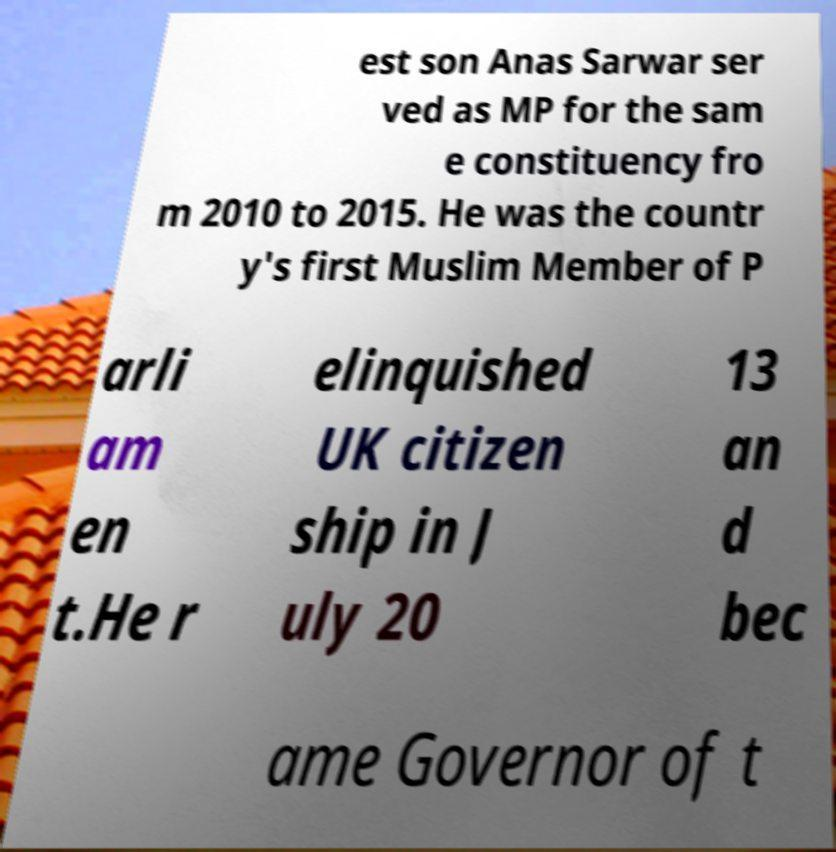Can you read and provide the text displayed in the image?This photo seems to have some interesting text. Can you extract and type it out for me? est son Anas Sarwar ser ved as MP for the sam e constituency fro m 2010 to 2015. He was the countr y's first Muslim Member of P arli am en t.He r elinquished UK citizen ship in J uly 20 13 an d bec ame Governor of t 